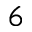<formula> <loc_0><loc_0><loc_500><loc_500>^ { 6 }</formula> 